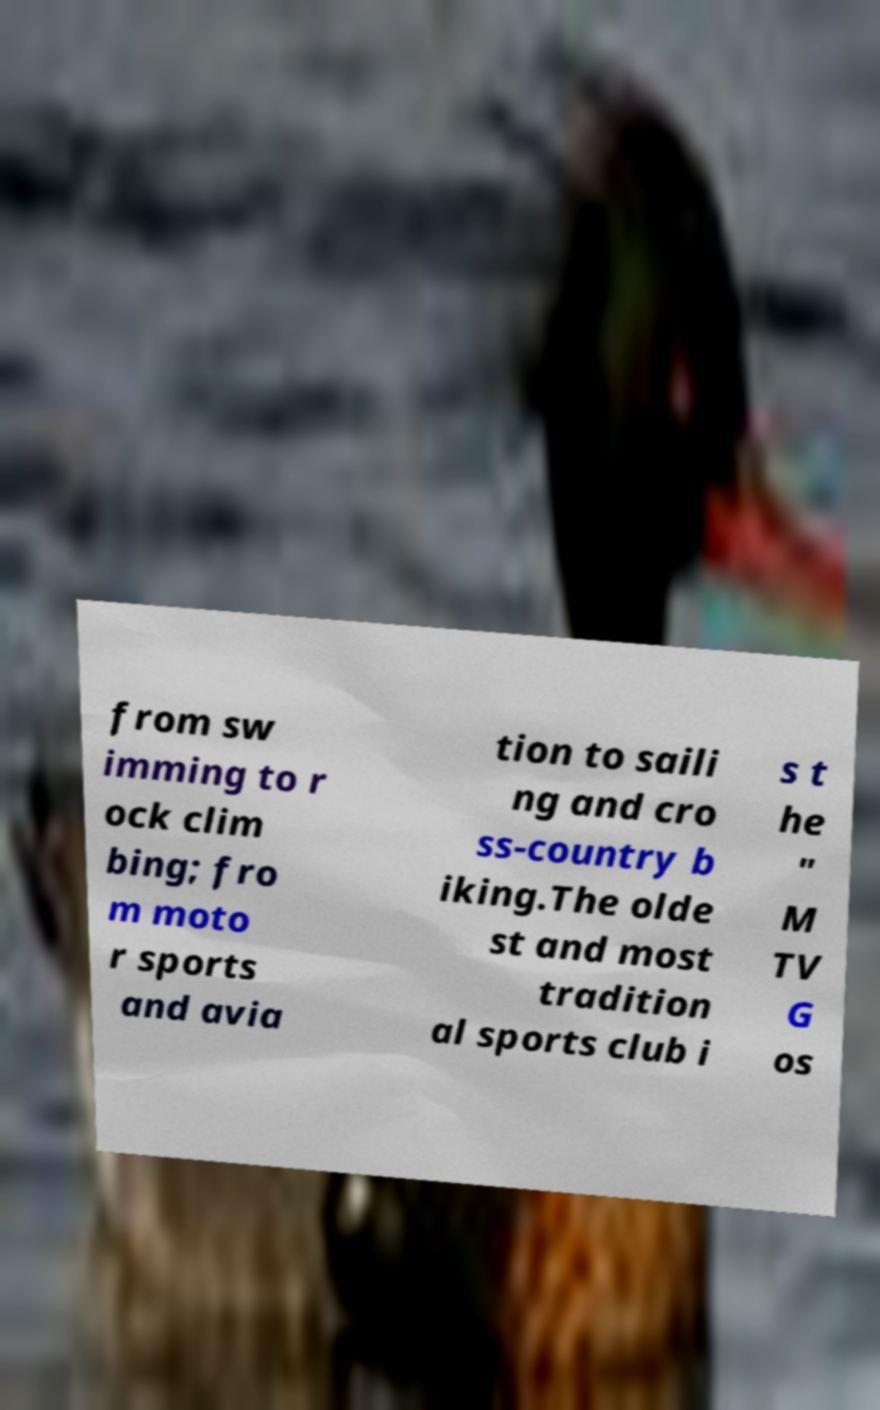Can you read and provide the text displayed in the image?This photo seems to have some interesting text. Can you extract and type it out for me? from sw imming to r ock clim bing; fro m moto r sports and avia tion to saili ng and cro ss-country b iking.The olde st and most tradition al sports club i s t he " M TV G os 